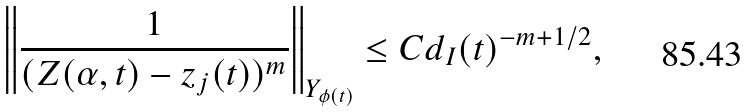<formula> <loc_0><loc_0><loc_500><loc_500>\left \| \frac { 1 } { ( Z ( \alpha , t ) - z _ { j } ( t ) ) ^ { m } } \right \| _ { Y _ { \phi ( t ) } } \leq C d _ { I } ( t ) ^ { - m + 1 / 2 } ,</formula> 